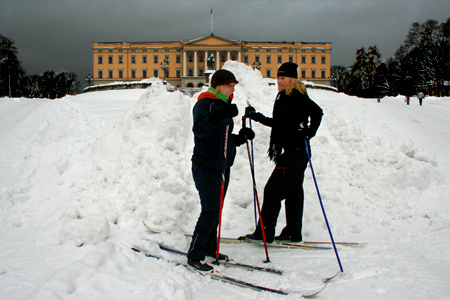Who wears a cap? The girl is the one wearing the cap. 